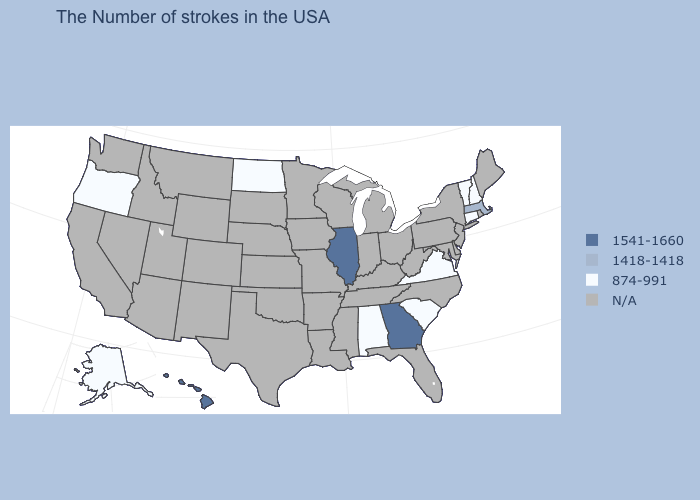What is the value of Idaho?
Answer briefly. N/A. What is the value of New Mexico?
Be succinct. N/A. Is the legend a continuous bar?
Concise answer only. No. Which states have the highest value in the USA?
Give a very brief answer. Georgia, Illinois, Hawaii. Does Massachusetts have the lowest value in the USA?
Short answer required. No. What is the value of South Dakota?
Answer briefly. N/A. Does Oregon have the lowest value in the USA?
Give a very brief answer. Yes. What is the value of North Carolina?
Keep it brief. N/A. What is the value of Nevada?
Concise answer only. N/A. Name the states that have a value in the range N/A?
Concise answer only. Maine, Rhode Island, New York, New Jersey, Delaware, Maryland, Pennsylvania, North Carolina, West Virginia, Ohio, Florida, Michigan, Kentucky, Indiana, Tennessee, Wisconsin, Mississippi, Louisiana, Missouri, Arkansas, Minnesota, Iowa, Kansas, Nebraska, Oklahoma, Texas, South Dakota, Wyoming, Colorado, New Mexico, Utah, Montana, Arizona, Idaho, Nevada, California, Washington. Name the states that have a value in the range 1418-1418?
Write a very short answer. Massachusetts. Does the first symbol in the legend represent the smallest category?
Short answer required. No. Which states have the highest value in the USA?
Quick response, please. Georgia, Illinois, Hawaii. What is the value of Iowa?
Quick response, please. N/A. Name the states that have a value in the range 874-991?
Concise answer only. New Hampshire, Vermont, Connecticut, Virginia, South Carolina, Alabama, North Dakota, Oregon, Alaska. 